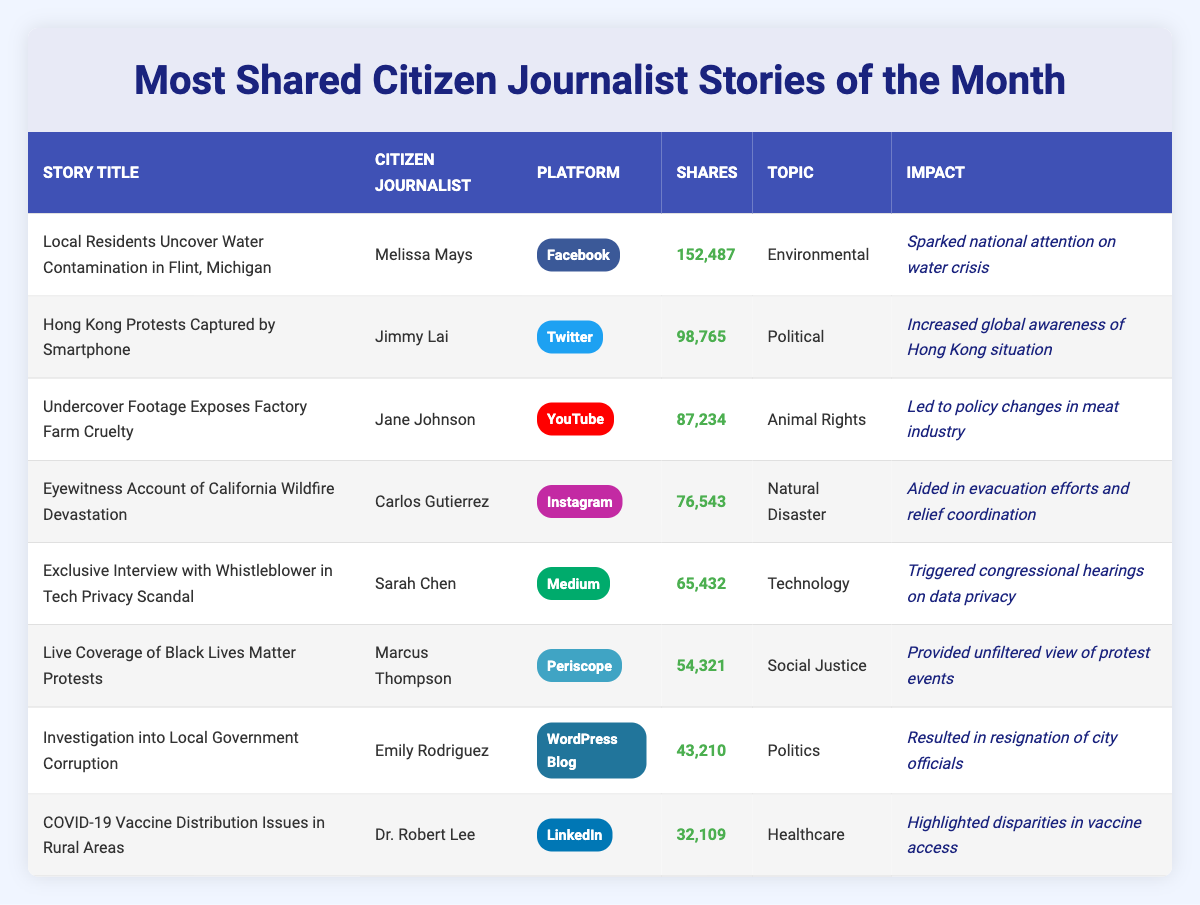What is the story title with the highest number of shares? The table shows the number of shares for each story. The highest number of shares is 152,487 for the story titled "Local Residents Uncover Water Contamination in Flint, Michigan".
Answer: Local Residents Uncover Water Contamination in Flint, Michigan Who is the citizen journalist associated with the story about factory farm cruelty? The table lists the citizen journalists for each story. The story about factory farm cruelty is attributed to "Jane Johnson".
Answer: Jane Johnson Which platform had the most shares for the story "COVID-19 Vaccine Distribution Issues in Rural Areas"? The table indicates that the shares for the story "COVID-19 Vaccine Distribution Issues in Rural Areas" were recorded on LinkedIn, with 32,109 shares.
Answer: LinkedIn How many shares did the "Live Coverage of Black Lives Matter Protests" receive? By looking at the table, the shares associated with "Live Coverage of Black Lives Matter Protests" are noted to be 54,321.
Answer: 54,321 What is the sum of shares for the top three stories? The top three stories' shares are 152,487 (Flint water contamination), 98,765 (Hong Kong protests), and 87,234 (Factory farm cruelty). Adding these together gives: 152,487 + 98,765 + 87,234 = 338,486.
Answer: 338,486 Did "Marcus Thompson" contribute the most shared story? The table shows that "Marcus Thompson" is associated with "Live Coverage of Black Lives Matter Protests" which has 54,321 shares, but the most shared story has 152,487 shares attributed to "Melissa Mays". Therefore, Marcus Thompson did not contribute the most shared story.
Answer: No Which story had the highest impact and what was its impact? The story with the highest impact listed in the data is "Local Residents Uncover Water Contamination in Flint, Michigan," which sparked national attention on the water crisis.
Answer: Sparked national attention on water crisis What is the difference in shares between the story with the most shares and the story with the fewest shares? The story with the most shares is "Local Residents Uncover Water Contamination in Flint, Michigan" (152,487 shares), and the story with the fewest shares is "COVID-19 Vaccine Distribution Issues in Rural Areas" (32,109 shares). The difference is 152,487 - 32,109 = 120,378.
Answer: 120,378 Which topics are covered by the stories shared on platforms like Facebook and Twitter? From the table, the story shared on Facebook is about "Environmental" issues, while the story on Twitter covers "Political" issues. The topics are thus "Environmental" and "Political".
Answer: Environmental, Political How many citizen journalists contributed stories on social media platforms? The table lists citizen journalists for stories on social media platforms: Facebook, Twitter, YouTube, and Instagram. There are four citizen journalists: Melissa Mays, Jimmy Lai, Jane Johnson, and Carlos Gutierrez.
Answer: 4 